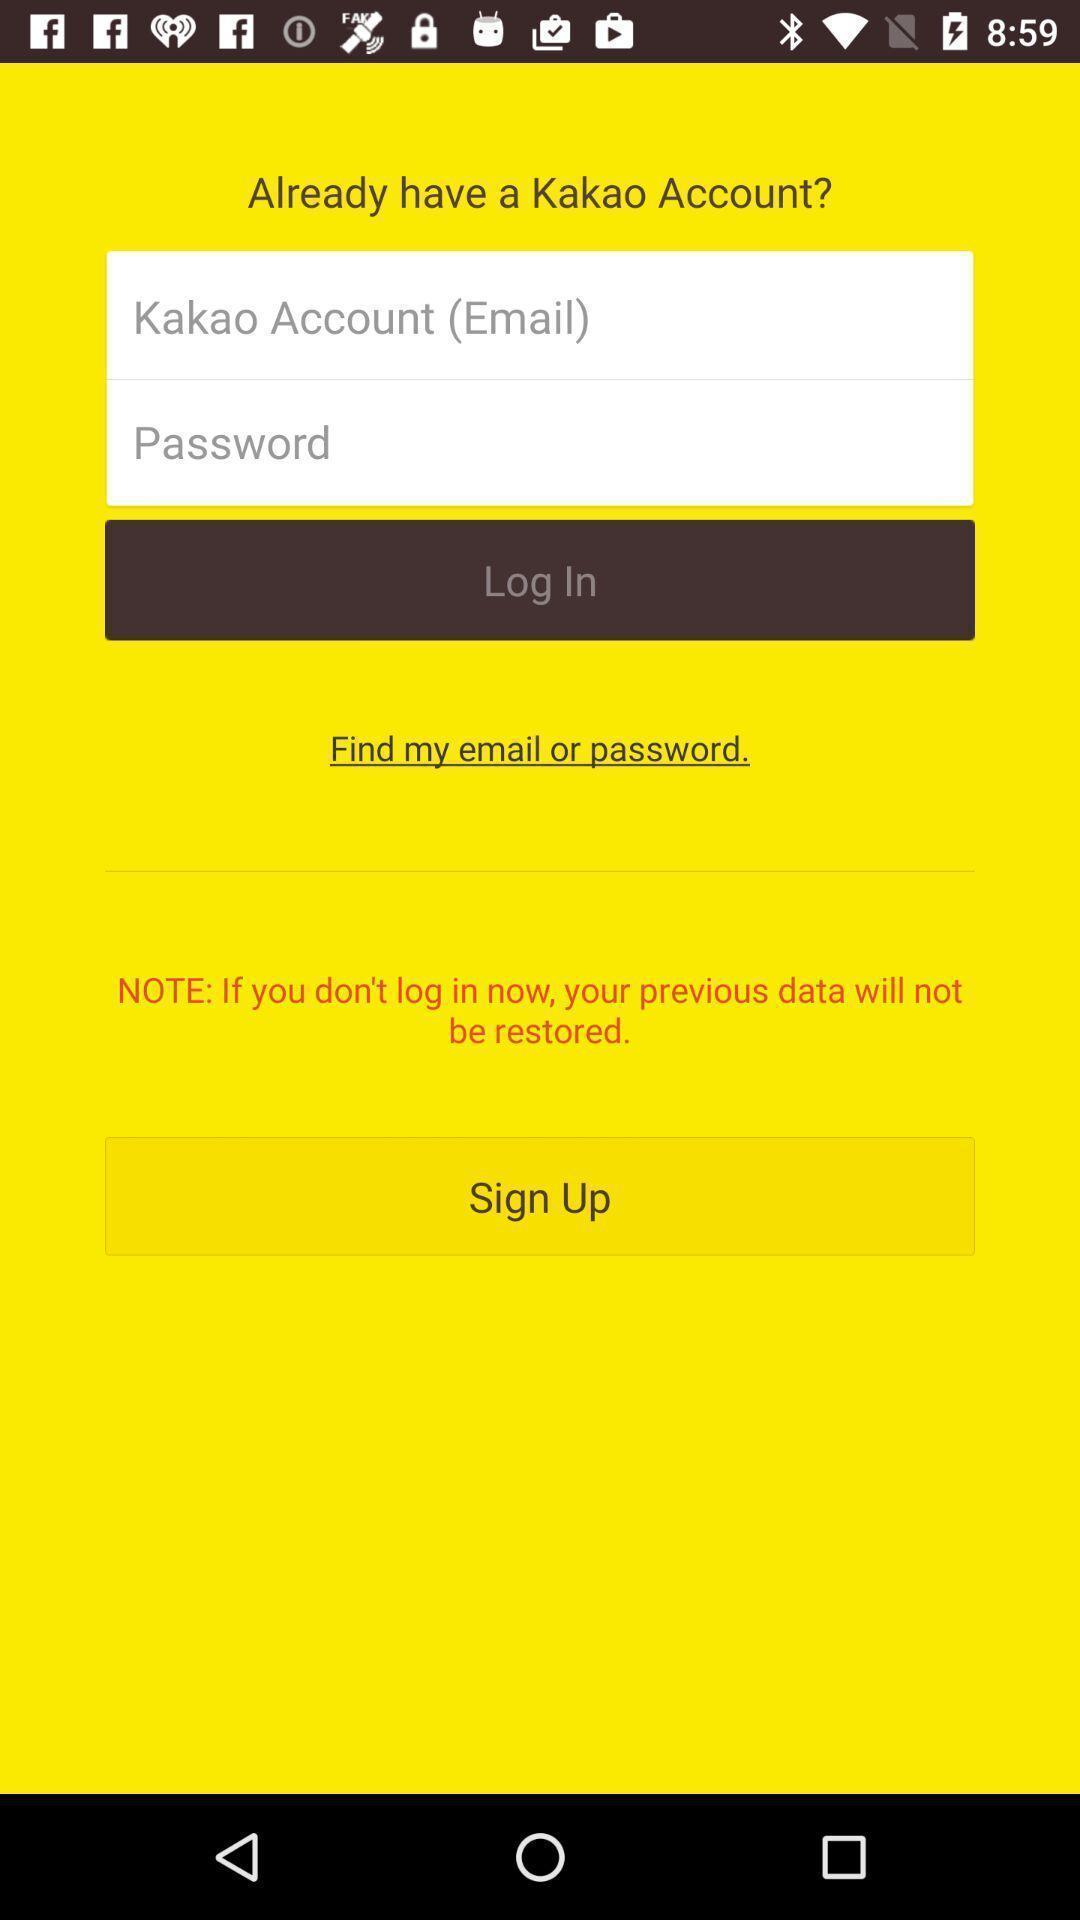Describe the visual elements of this screenshot. Sign up page of free chats and messages app. 